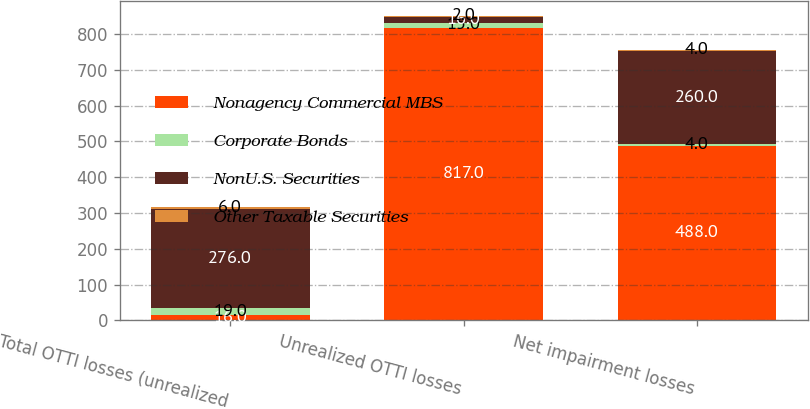<chart> <loc_0><loc_0><loc_500><loc_500><stacked_bar_chart><ecel><fcel>Total OTTI losses (unrealized<fcel>Unrealized OTTI losses<fcel>Net impairment losses<nl><fcel>Nonagency Commercial MBS<fcel>16<fcel>817<fcel>488<nl><fcel>Corporate Bonds<fcel>19<fcel>15<fcel>4<nl><fcel>NonU.S. Securities<fcel>276<fcel>16<fcel>260<nl><fcel>Other Taxable Securities<fcel>6<fcel>2<fcel>4<nl></chart> 